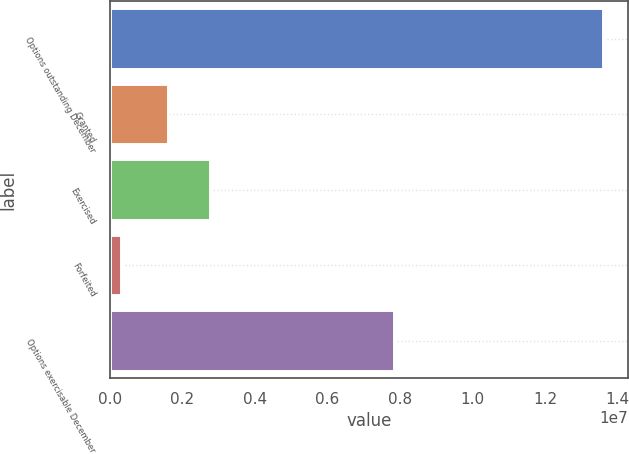Convert chart. <chart><loc_0><loc_0><loc_500><loc_500><bar_chart><fcel>Options outstanding December<fcel>Granted<fcel>Exercised<fcel>Forfeited<fcel>Options exercisable December<nl><fcel>1.35976e+07<fcel>1.61251e+06<fcel>2.77589e+06<fcel>309026<fcel>7.83922e+06<nl></chart> 